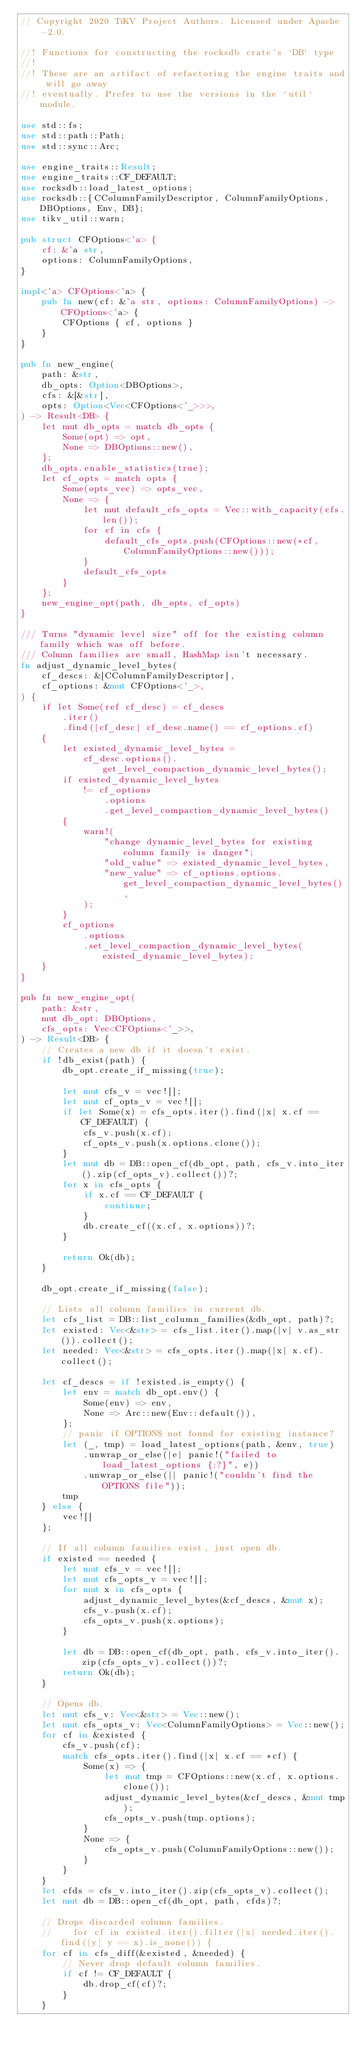Convert code to text. <code><loc_0><loc_0><loc_500><loc_500><_Rust_>// Copyright 2020 TiKV Project Authors. Licensed under Apache-2.0.

//! Functions for constructing the rocksdb crate's `DB` type
//!
//! These are an artifact of refactoring the engine traits and will go away
//! eventually. Prefer to use the versions in the `util` module.

use std::fs;
use std::path::Path;
use std::sync::Arc;

use engine_traits::Result;
use engine_traits::CF_DEFAULT;
use rocksdb::load_latest_options;
use rocksdb::{CColumnFamilyDescriptor, ColumnFamilyOptions, DBOptions, Env, DB};
use tikv_util::warn;

pub struct CFOptions<'a> {
    cf: &'a str,
    options: ColumnFamilyOptions,
}

impl<'a> CFOptions<'a> {
    pub fn new(cf: &'a str, options: ColumnFamilyOptions) -> CFOptions<'a> {
        CFOptions { cf, options }
    }
}

pub fn new_engine(
    path: &str,
    db_opts: Option<DBOptions>,
    cfs: &[&str],
    opts: Option<Vec<CFOptions<'_>>>,
) -> Result<DB> {
    let mut db_opts = match db_opts {
        Some(opt) => opt,
        None => DBOptions::new(),
    };
    db_opts.enable_statistics(true);
    let cf_opts = match opts {
        Some(opts_vec) => opts_vec,
        None => {
            let mut default_cfs_opts = Vec::with_capacity(cfs.len());
            for cf in cfs {
                default_cfs_opts.push(CFOptions::new(*cf, ColumnFamilyOptions::new()));
            }
            default_cfs_opts
        }
    };
    new_engine_opt(path, db_opts, cf_opts)
}

/// Turns "dynamic level size" off for the existing column family which was off before.
/// Column families are small, HashMap isn't necessary.
fn adjust_dynamic_level_bytes(
    cf_descs: &[CColumnFamilyDescriptor],
    cf_options: &mut CFOptions<'_>,
) {
    if let Some(ref cf_desc) = cf_descs
        .iter()
        .find(|cf_desc| cf_desc.name() == cf_options.cf)
    {
        let existed_dynamic_level_bytes =
            cf_desc.options().get_level_compaction_dynamic_level_bytes();
        if existed_dynamic_level_bytes
            != cf_options
                .options
                .get_level_compaction_dynamic_level_bytes()
        {
            warn!(
                "change dynamic_level_bytes for existing column family is danger";
                "old_value" => existed_dynamic_level_bytes,
                "new_value" => cf_options.options.get_level_compaction_dynamic_level_bytes(),
            );
        }
        cf_options
            .options
            .set_level_compaction_dynamic_level_bytes(existed_dynamic_level_bytes);
    }
}

pub fn new_engine_opt(
    path: &str,
    mut db_opt: DBOptions,
    cfs_opts: Vec<CFOptions<'_>>,
) -> Result<DB> {
    // Creates a new db if it doesn't exist.
    if !db_exist(path) {
        db_opt.create_if_missing(true);

        let mut cfs_v = vec![];
        let mut cf_opts_v = vec![];
        if let Some(x) = cfs_opts.iter().find(|x| x.cf == CF_DEFAULT) {
            cfs_v.push(x.cf);
            cf_opts_v.push(x.options.clone());
        }
        let mut db = DB::open_cf(db_opt, path, cfs_v.into_iter().zip(cf_opts_v).collect())?;
        for x in cfs_opts {
            if x.cf == CF_DEFAULT {
                continue;
            }
            db.create_cf((x.cf, x.options))?;
        }

        return Ok(db);
    }

    db_opt.create_if_missing(false);

    // Lists all column families in current db.
    let cfs_list = DB::list_column_families(&db_opt, path)?;
    let existed: Vec<&str> = cfs_list.iter().map(|v| v.as_str()).collect();
    let needed: Vec<&str> = cfs_opts.iter().map(|x| x.cf).collect();

    let cf_descs = if !existed.is_empty() {
        let env = match db_opt.env() {
            Some(env) => env,
            None => Arc::new(Env::default()),
        };
        // panic if OPTIONS not found for existing instance?
        let (_, tmp) = load_latest_options(path, &env, true)
            .unwrap_or_else(|e| panic!("failed to load_latest_options {:?}", e))
            .unwrap_or_else(|| panic!("couldn't find the OPTIONS file"));
        tmp
    } else {
        vec![]
    };

    // If all column families exist, just open db.
    if existed == needed {
        let mut cfs_v = vec![];
        let mut cfs_opts_v = vec![];
        for mut x in cfs_opts {
            adjust_dynamic_level_bytes(&cf_descs, &mut x);
            cfs_v.push(x.cf);
            cfs_opts_v.push(x.options);
        }

        let db = DB::open_cf(db_opt, path, cfs_v.into_iter().zip(cfs_opts_v).collect())?;
        return Ok(db);
    }

    // Opens db.
    let mut cfs_v: Vec<&str> = Vec::new();
    let mut cfs_opts_v: Vec<ColumnFamilyOptions> = Vec::new();
    for cf in &existed {
        cfs_v.push(cf);
        match cfs_opts.iter().find(|x| x.cf == *cf) {
            Some(x) => {
                let mut tmp = CFOptions::new(x.cf, x.options.clone());
                adjust_dynamic_level_bytes(&cf_descs, &mut tmp);
                cfs_opts_v.push(tmp.options);
            }
            None => {
                cfs_opts_v.push(ColumnFamilyOptions::new());
            }
        }
    }
    let cfds = cfs_v.into_iter().zip(cfs_opts_v).collect();
    let mut db = DB::open_cf(db_opt, path, cfds)?;

    // Drops discarded column families.
    //    for cf in existed.iter().filter(|x| needed.iter().find(|y| y == x).is_none()) {
    for cf in cfs_diff(&existed, &needed) {
        // Never drop default column families.
        if cf != CF_DEFAULT {
            db.drop_cf(cf)?;
        }
    }
</code> 